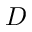Convert formula to latex. <formula><loc_0><loc_0><loc_500><loc_500>D</formula> 